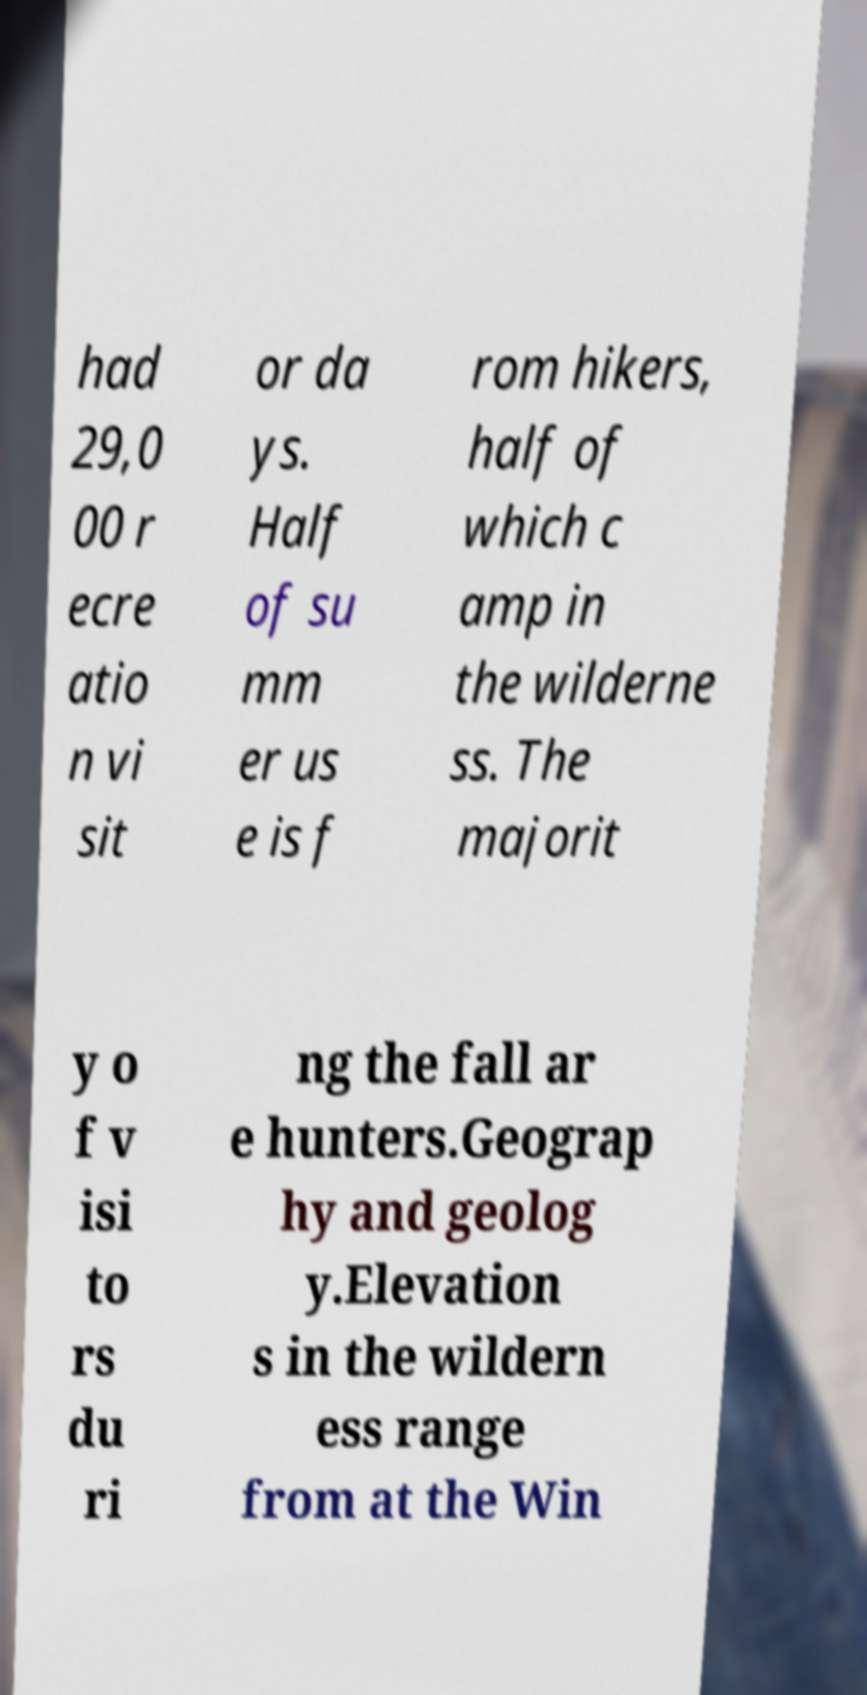Can you accurately transcribe the text from the provided image for me? had 29,0 00 r ecre atio n vi sit or da ys. Half of su mm er us e is f rom hikers, half of which c amp in the wilderne ss. The majorit y o f v isi to rs du ri ng the fall ar e hunters.Geograp hy and geolog y.Elevation s in the wildern ess range from at the Win 